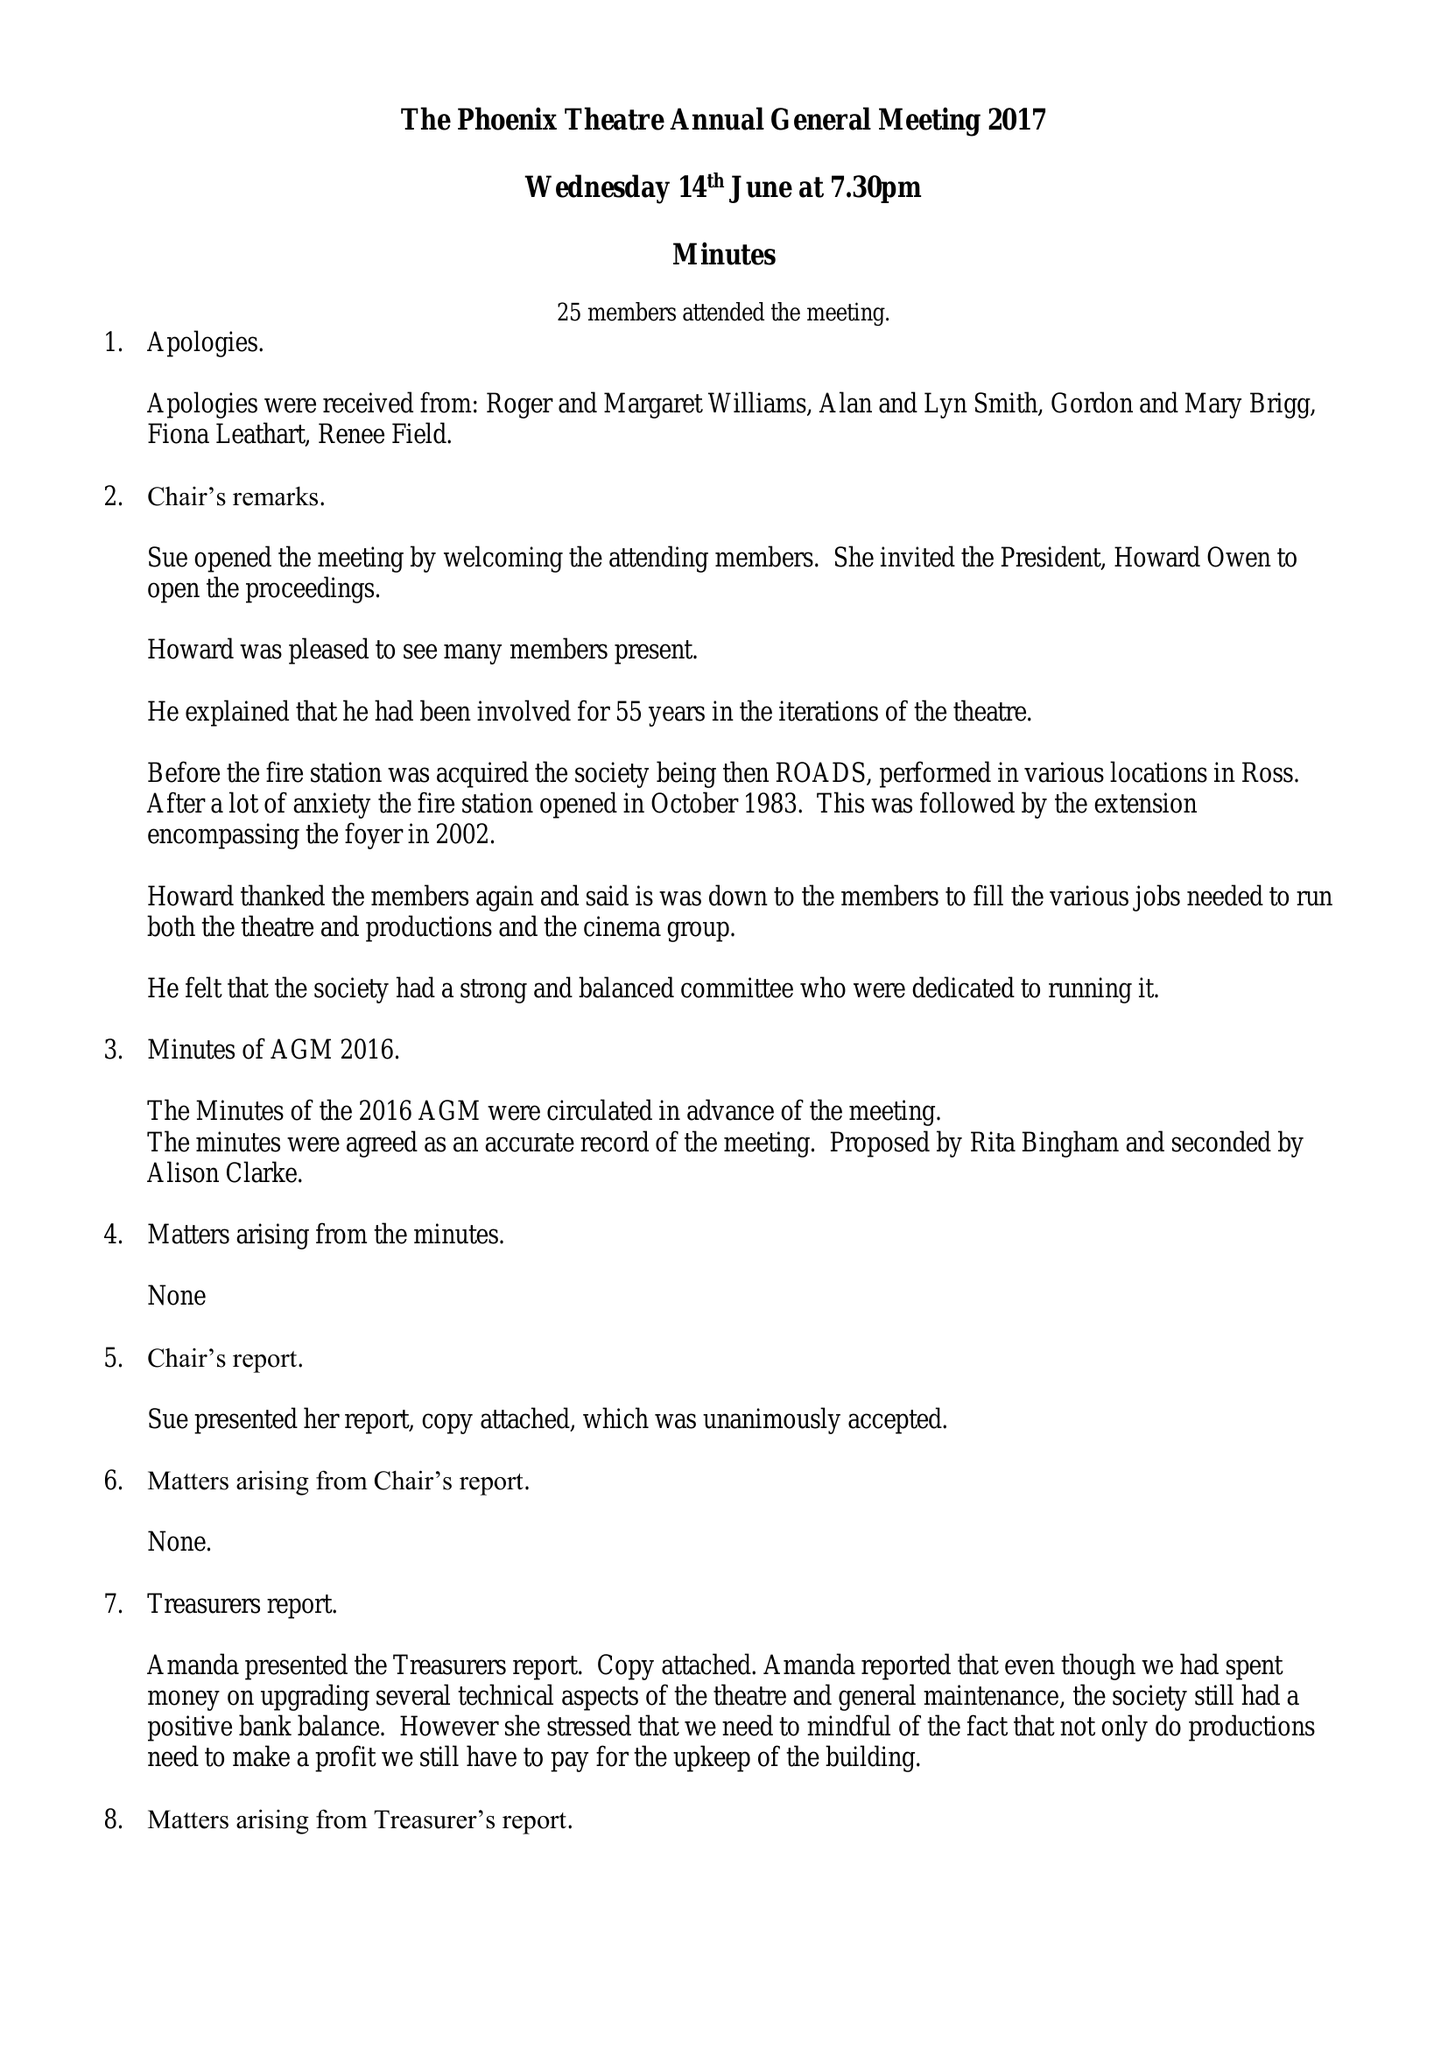What is the value for the address__street_line?
Answer the question using a single word or phrase. THE WOODLANDS 